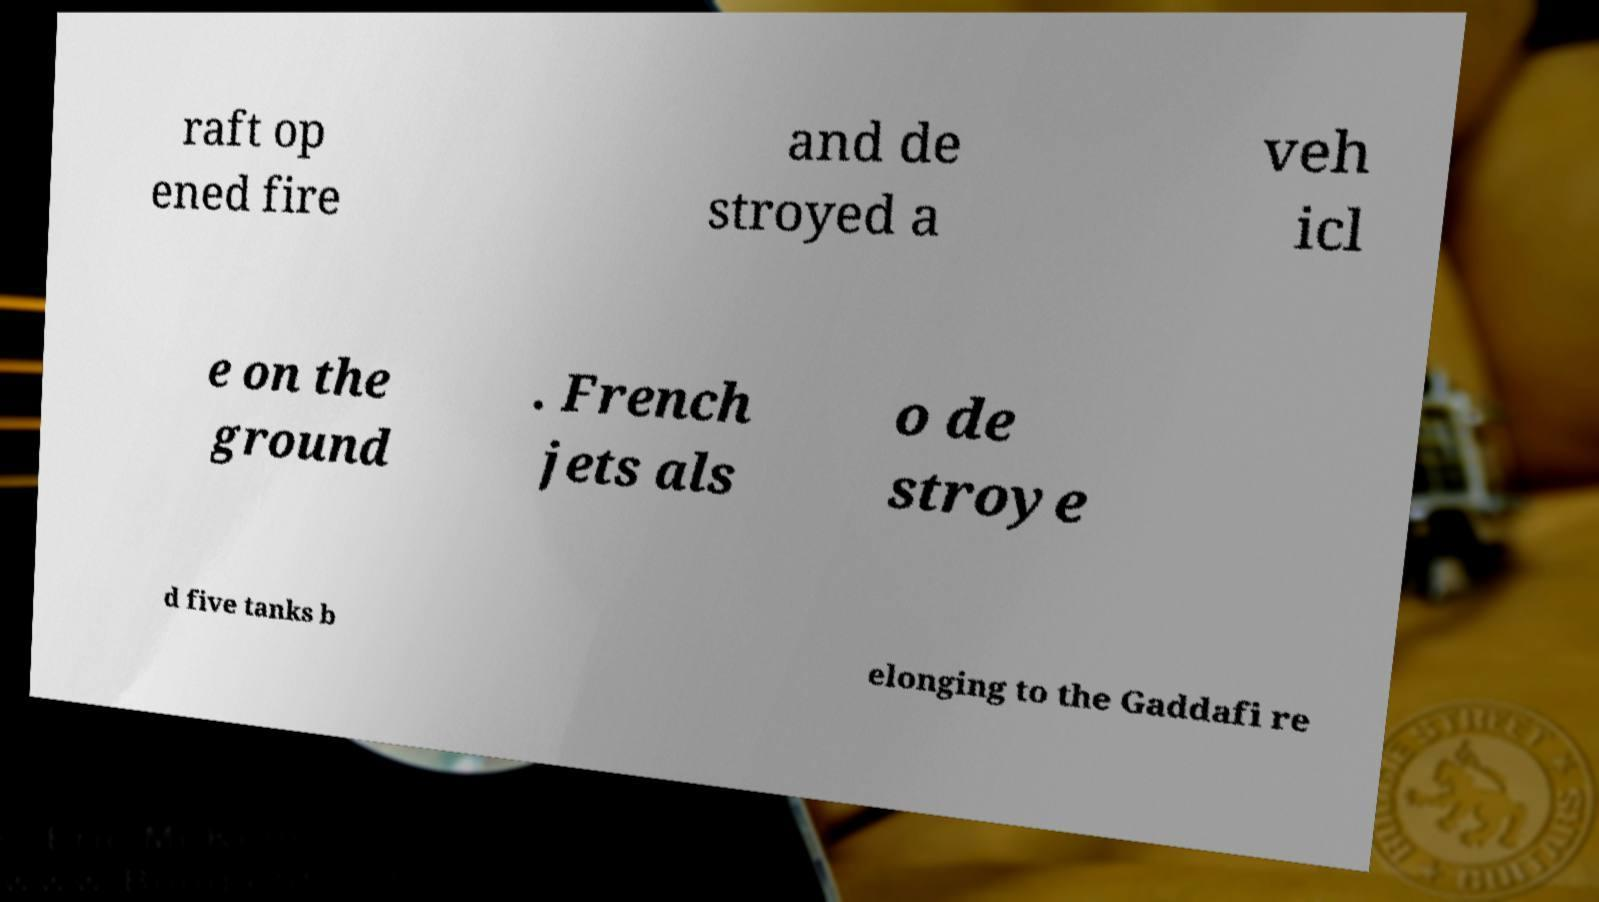Could you extract and type out the text from this image? raft op ened fire and de stroyed a veh icl e on the ground . French jets als o de stroye d five tanks b elonging to the Gaddafi re 